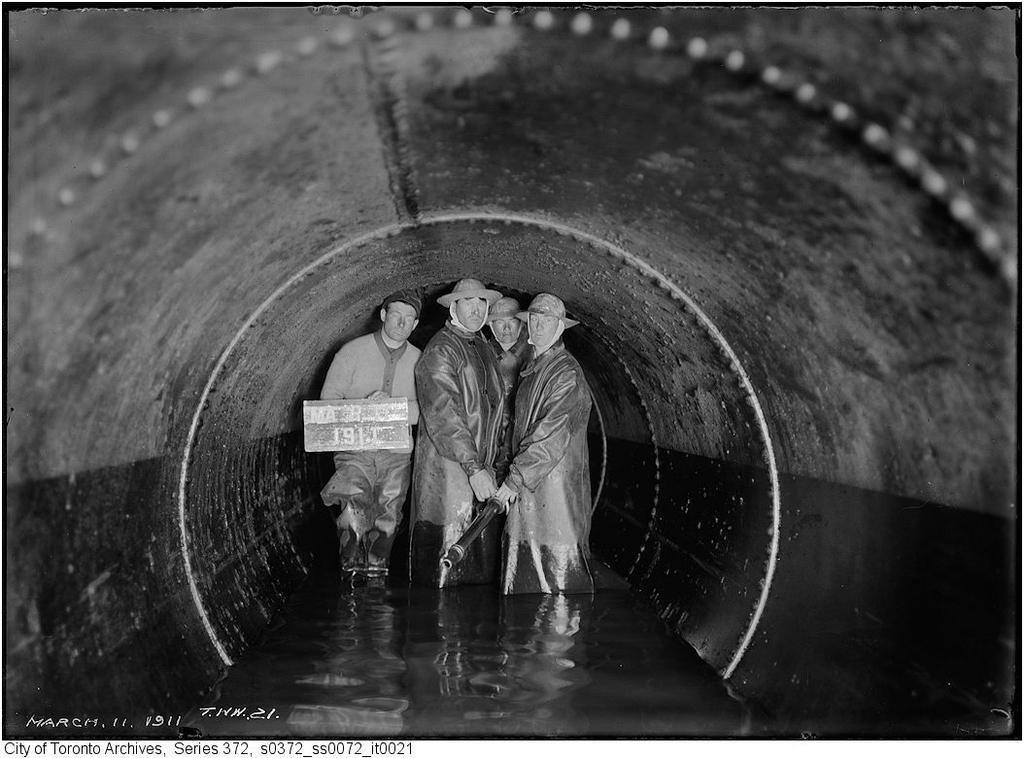Can you describe this image briefly? Here men are standing in the water, this is tunnel. 